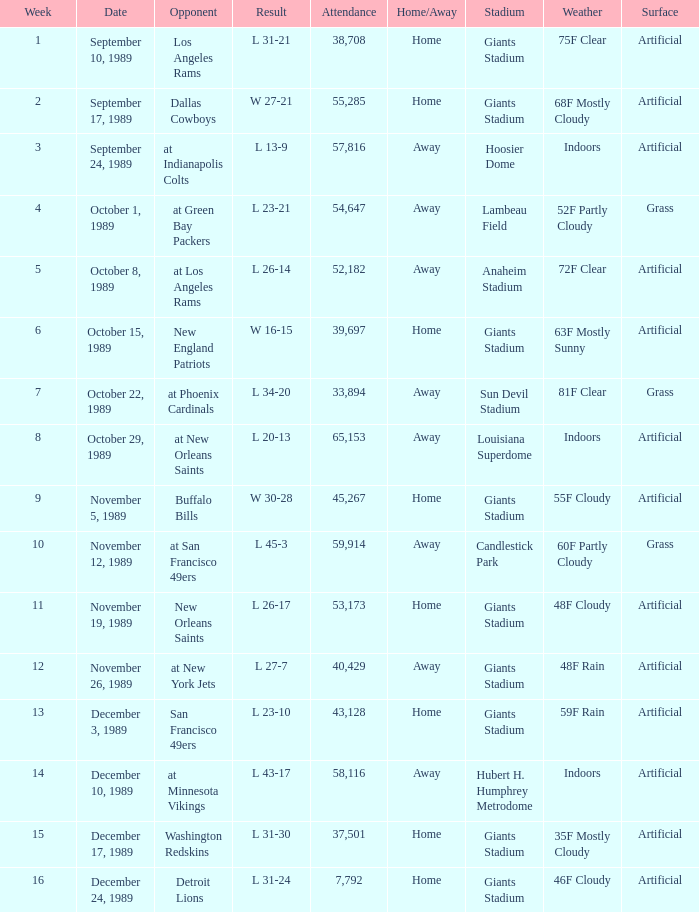For what week was the attendance 40,429? 12.0. 